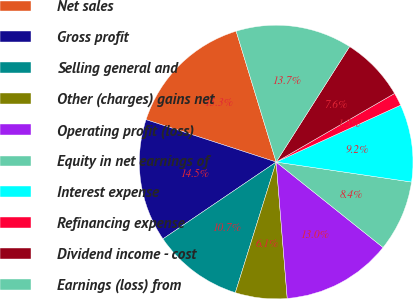Convert chart to OTSL. <chart><loc_0><loc_0><loc_500><loc_500><pie_chart><fcel>Net sales<fcel>Gross profit<fcel>Selling general and<fcel>Other (charges) gains net<fcel>Operating profit (loss)<fcel>Equity in net earnings of<fcel>Interest expense<fcel>Refinancing expense<fcel>Dividend income - cost<fcel>Earnings (loss) from<nl><fcel>15.27%<fcel>14.5%<fcel>10.69%<fcel>6.11%<fcel>12.98%<fcel>8.4%<fcel>9.16%<fcel>1.53%<fcel>7.63%<fcel>13.74%<nl></chart> 